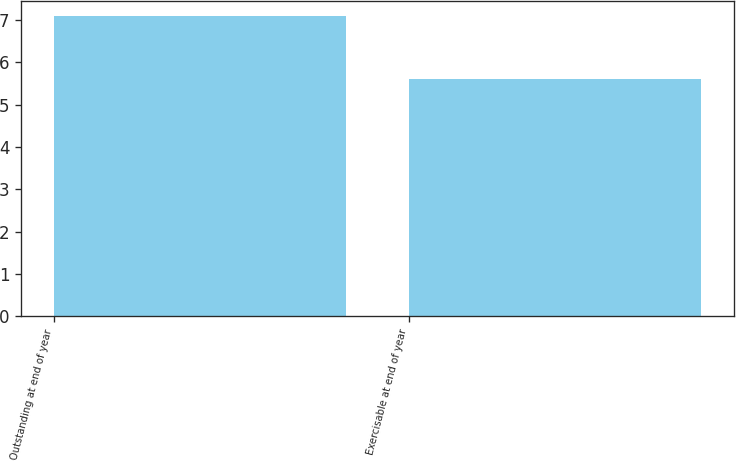Convert chart to OTSL. <chart><loc_0><loc_0><loc_500><loc_500><bar_chart><fcel>Outstanding at end of year<fcel>Exercisable at end of year<nl><fcel>7.09<fcel>5.61<nl></chart> 